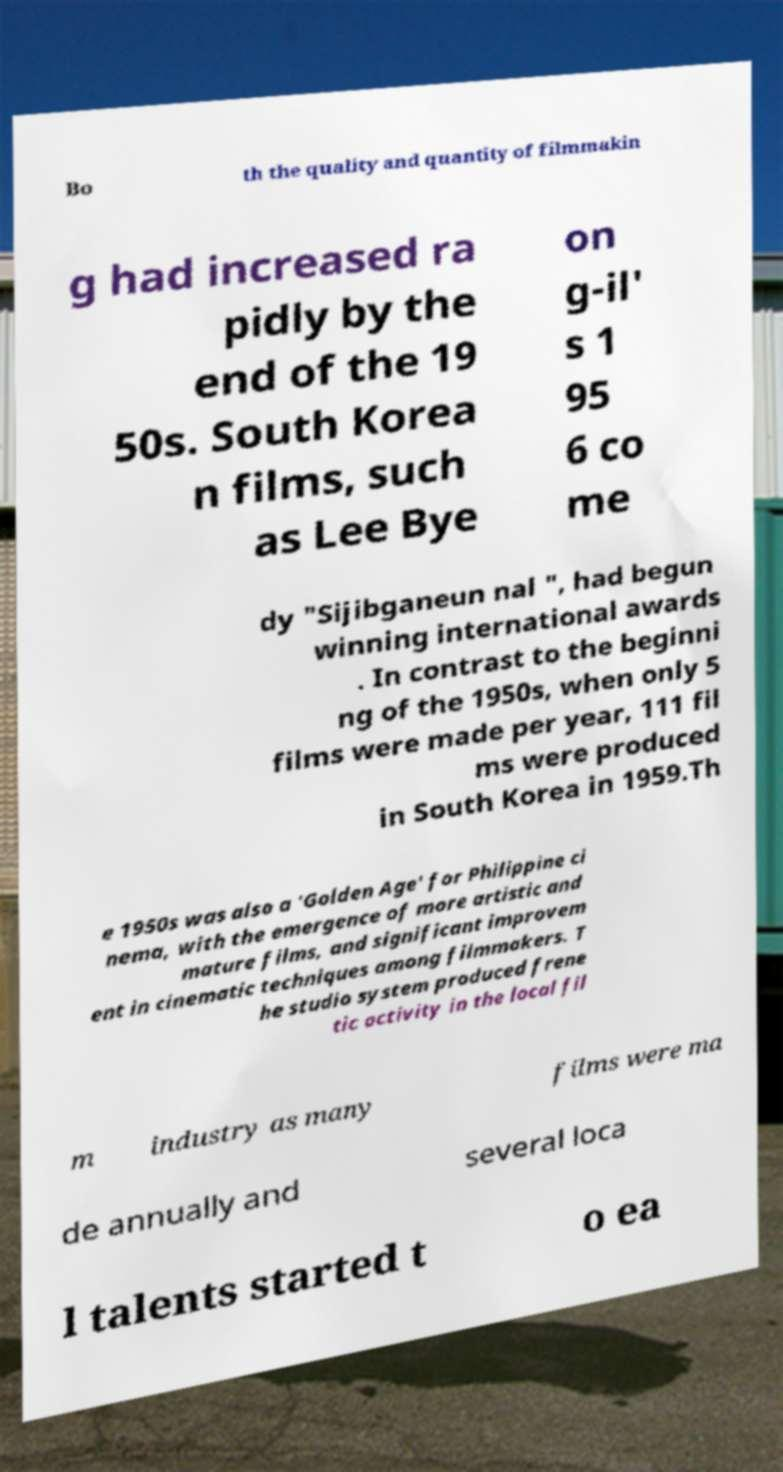For documentation purposes, I need the text within this image transcribed. Could you provide that? Bo th the quality and quantity of filmmakin g had increased ra pidly by the end of the 19 50s. South Korea n films, such as Lee Bye on g-il' s 1 95 6 co me dy "Sijibganeun nal ", had begun winning international awards . In contrast to the beginni ng of the 1950s, when only 5 films were made per year, 111 fil ms were produced in South Korea in 1959.Th e 1950s was also a 'Golden Age' for Philippine ci nema, with the emergence of more artistic and mature films, and significant improvem ent in cinematic techniques among filmmakers. T he studio system produced frene tic activity in the local fil m industry as many films were ma de annually and several loca l talents started t o ea 